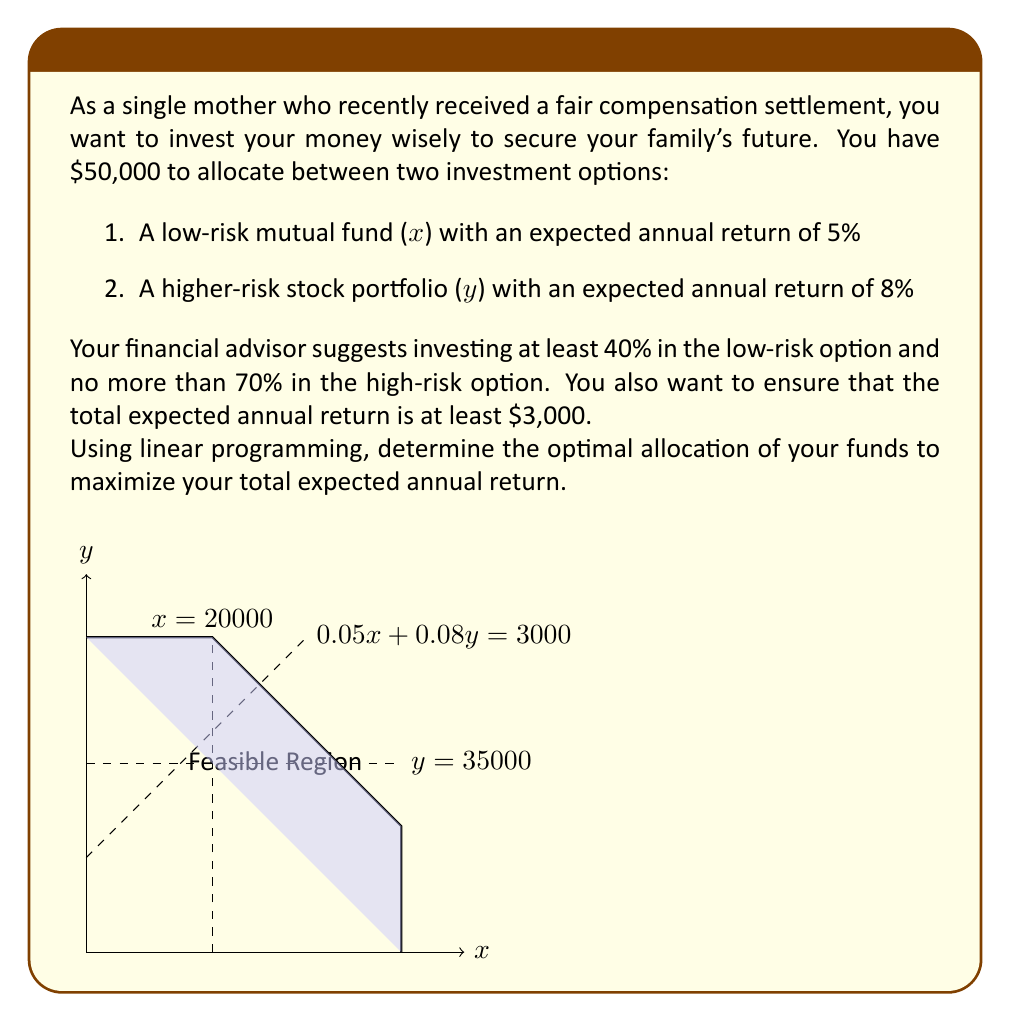Could you help me with this problem? Let's solve this problem step by step using linear programming:

1) Define variables:
   $x$ = amount invested in the low-risk mutual fund
   $y$ = amount invested in the high-risk stock portfolio

2) Objective function (maximize total expected return):
   Maximize $Z = 0.05x + 0.08y$

3) Constraints:
   a) Total investment: $x + y = 50000$
   b) At least 40% in low-risk: $x \geq 0.4(50000) = 20000$
   c) No more than 70% in high-risk: $y \leq 0.7(50000) = 35000$
   d) Minimum total return: $0.05x + 0.08y \geq 3000$
   e) Non-negativity: $x \geq 0, y \geq 0$

4) Graph the constraints and identify the feasible region (shown in the figure).

5) The optimal solution will be at one of the corner points of the feasible region. Let's evaluate these points:

   Point A (20000, 30000): $Z = 0.05(20000) + 0.08(30000) = 3400$
   Point B (20000, 35000): $Z = 0.05(20000) + 0.08(35000) = 3800$
   Point C (15000, 35000): $Z = 0.05(15000) + 0.08(35000) = 3550$

6) The maximum value of Z occurs at point B (20000, 35000).

Therefore, the optimal allocation is:
$x = 20000$ (low-risk mutual fund)
$y = 35000$ (high-risk stock portfolio)

This allocation maximizes the total expected annual return at $3800.
Answer: Invest $20,000 in the low-risk mutual fund and $35,000 in the high-risk stock portfolio. 